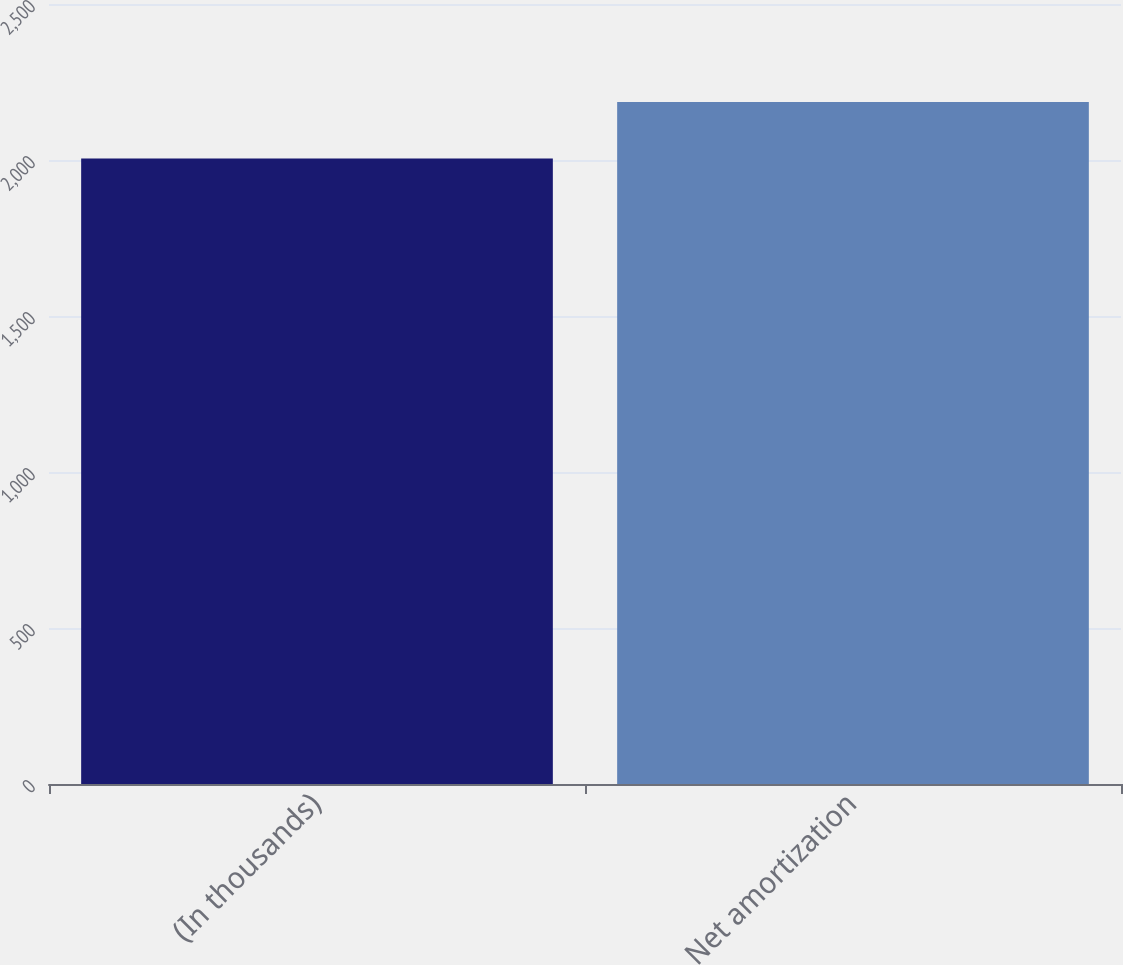<chart> <loc_0><loc_0><loc_500><loc_500><bar_chart><fcel>(In thousands)<fcel>Net amortization<nl><fcel>2005<fcel>2186<nl></chart> 